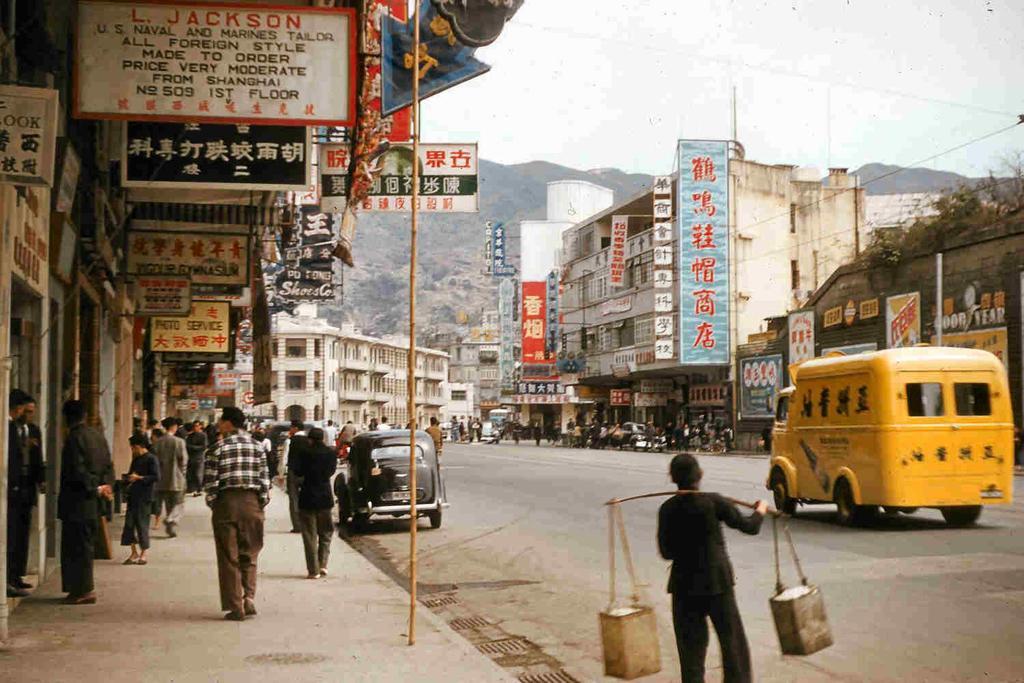Describe this image in one or two sentences. In this picture there are people, among them there is a person holding a stick with metal tins. We can see boards, vehicles on the road, buildings, plants and hills. In the background of the image we can see the sky. 